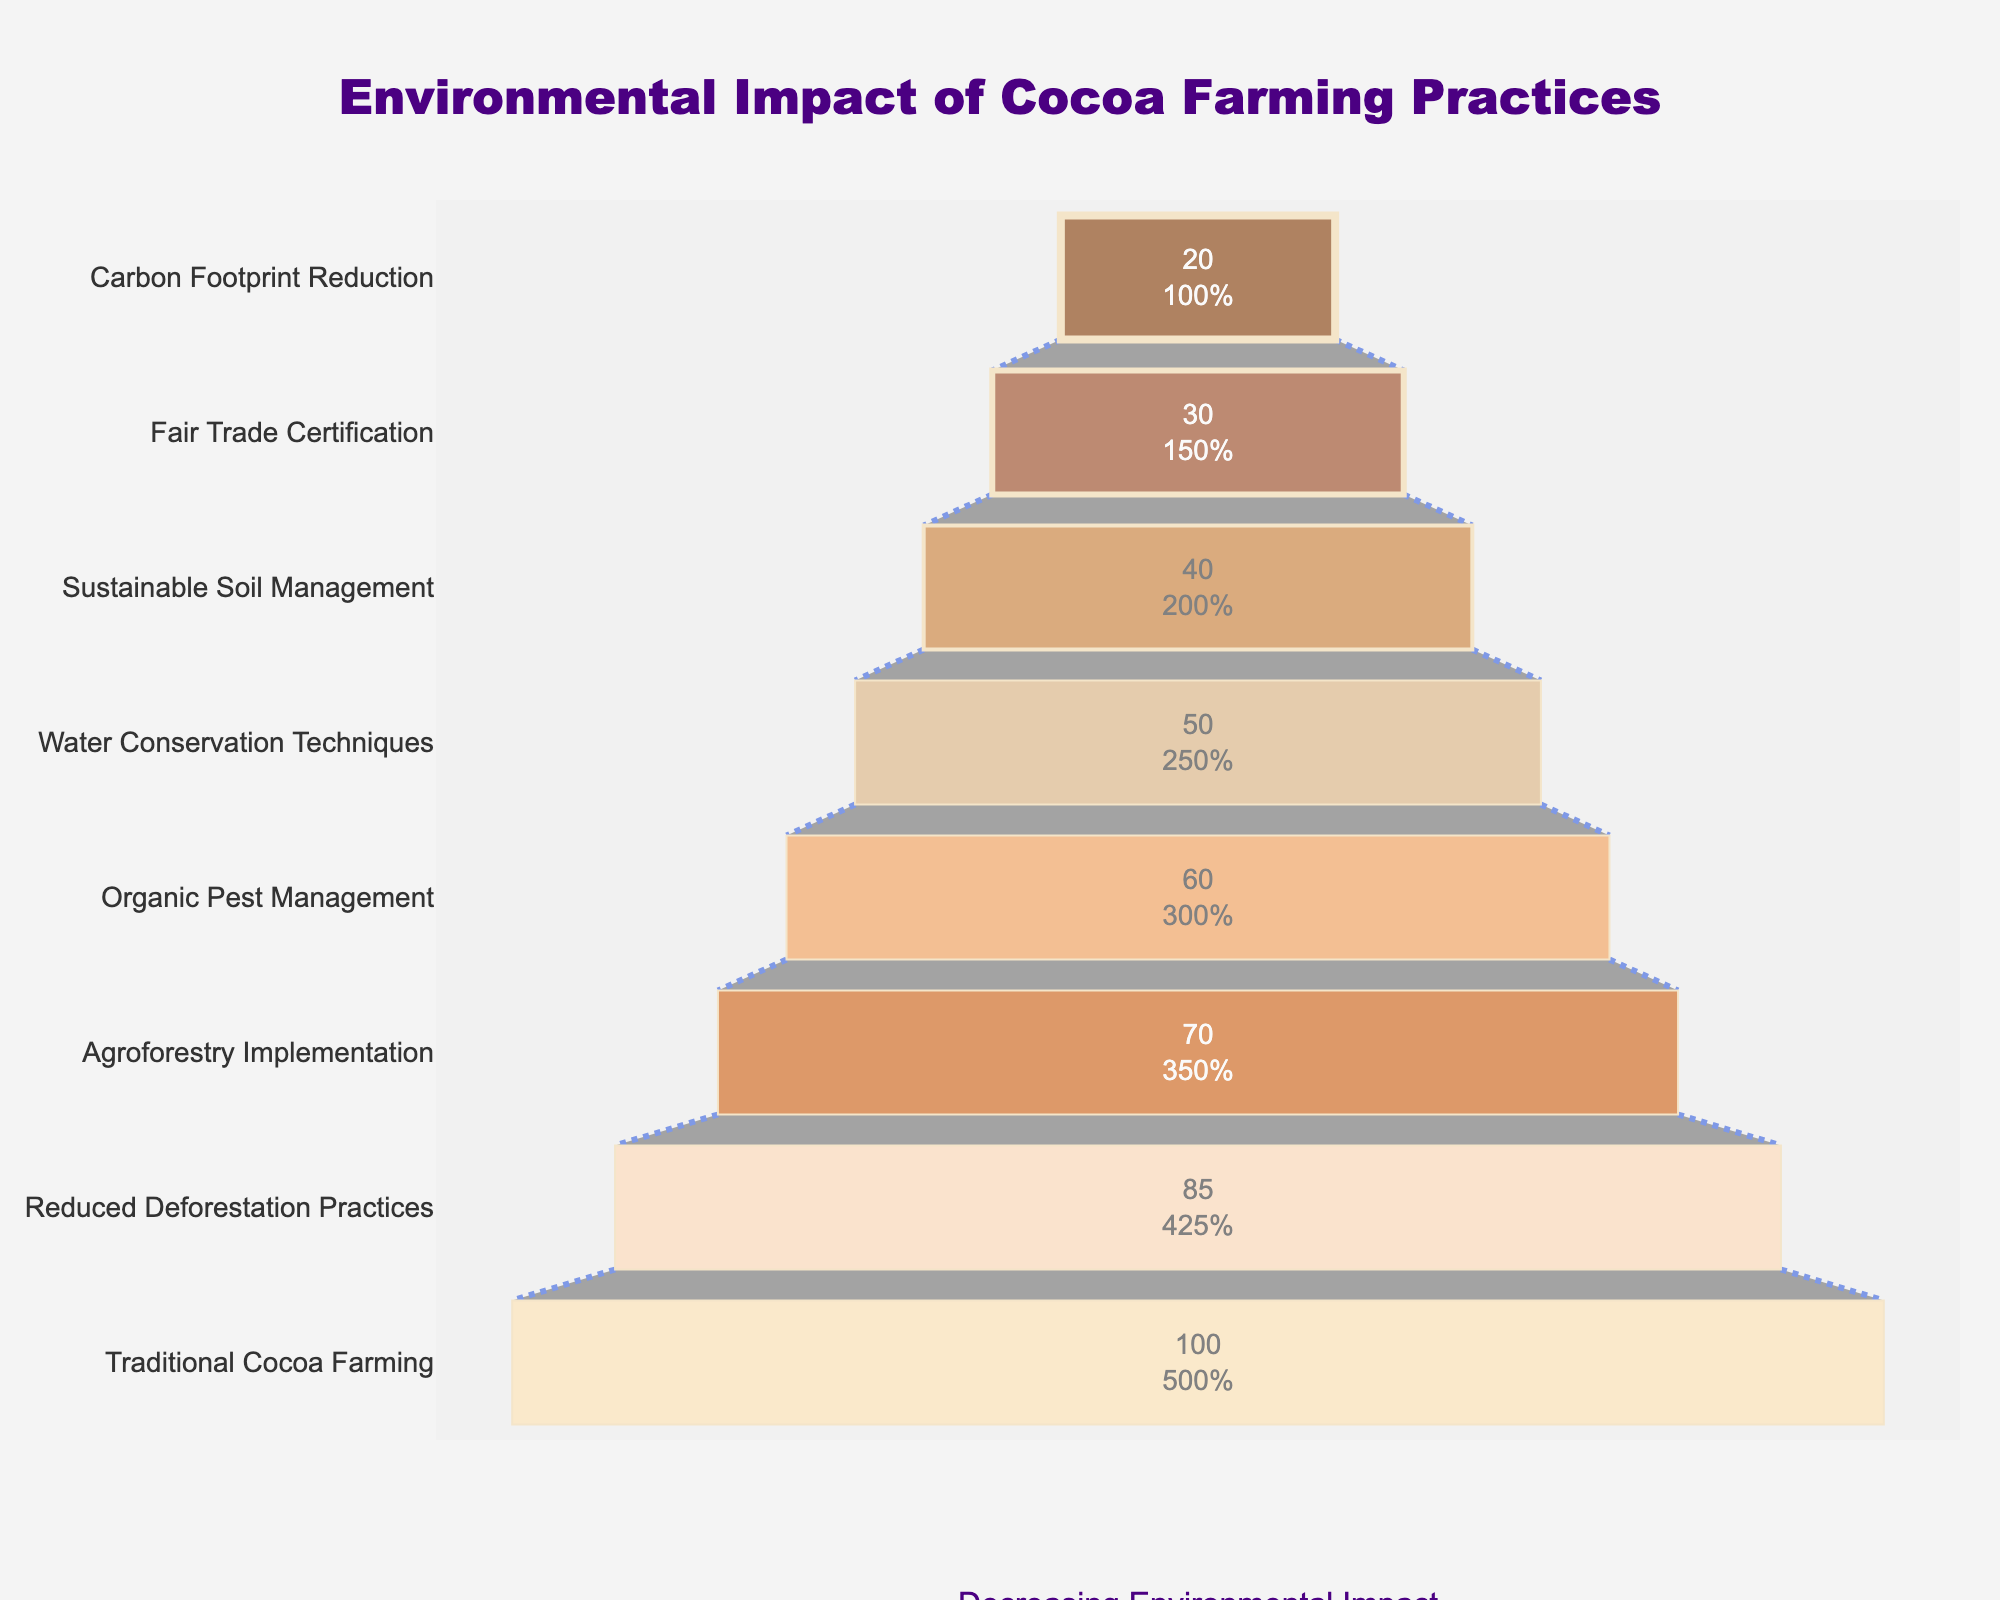What's the title of the funnel chart? The title is clearly displayed at the top center of the funnel chart. This can be easily read as "Environmental Impact of Cocoa Farming Practices."
Answer: Environmental Impact of Cocoa Farming Practices How many stages are represented in the funnel chart? By counting the number of distinct stages on the y-axis from top to bottom, we can determine that there are 8 stages depicted in the chart.
Answer: 8 stages What is the Environmental Impact Score for Traditional Cocoa Farming? The Environmental Impact Score for Traditional Cocoa Farming is visible where the y-axis label "Traditional Cocoa Farming" intersects the corresponding bar, showing a value of 100.
Answer: 100 What stage has the lowest Environmental Impact Score? By examining the bottom of the funnel chart, we can determine that the last stage mentioned is "Carbon Footprint Reduction" with an environmental impact score of 20.
Answer: Carbon Footprint Reduction What is the difference in Environmental Impact Score between Traditional Cocoa Farming and Fair Trade Certification? We can find the Environmental Impact Scores for Traditional Cocoa Farming (100) and Fair Trade Certification (30). Subtracting the Fair Trade Certification score from the Traditional Cocoa Farming score gives 100 - 30 = 70.
Answer: 70 Which practice reduced the Environmental Impact Score by the greatest amount compared to the previous stage? By comparing the differences in scores between each consecutive stage, the largest reduction is from Traditional Cocoa Farming (100) to Reduced Deforestation Practices (85), which results in a decrease of 15 points.
Answer: Reduced Deforestation Practices What is the average Environmental Impact Score of all the stages? Summing all the scores (100 + 85 + 70 + 60 + 50 + 40 + 30 + 20) equals 455, and dividing by the number of stages (8) gives an average score of 455 / 8 = 56.875.
Answer: 56.875 Which two consecutive stages have the smallest reduction in Environmental Impact Score? By examining the score reductions between every consecutive stage: Traditional Cocoa Farming to Reduced Deforestation Practices (15), Reduced Deforestation Practices to Agroforestry Implementation (15), Agroforestry Implementation to Organic Pest Management (10), Organic Pest Management to Water Conservation Techniques (10), Water Conservation Techniques to Sustainable Soil Management (10), Sustainable Soil Management to Fair Trade Certification (10), and Fair Trade Certification to Carbon Footprint Reduction (10), the smallest reduction observed is between multiple stages, each with a reduction of 10 points.
Answer: Organic Pest Management to Water Conservation Techniques What overall trend is depicted in the funnel chart? Observing the scores at each stage from top to bottom, it is clear that the Environmental Impact Score steadily decreases as more sustainable practices are implemented, indicating a consistent reduction in environmental impact through better practices.
Answer: Decreasing environmental impact By how many points does the Environmental Impact Score decrease from top to bottom of the funnel chart? The score starts at 100 at the top (Traditional Cocoa Farming) and goes down to 20 at the bottom (Carbon Footprint Reduction). The total decrease is 100 - 20 = 80 points.
Answer: 80 points 